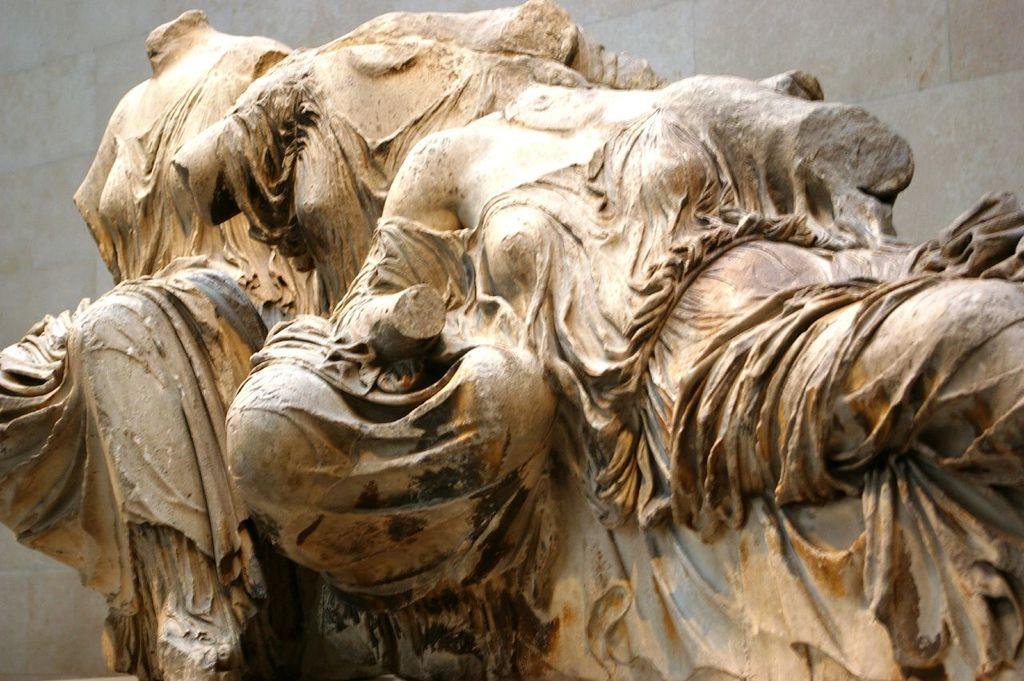What type of objects are depicted in the image? There are statues of persons in the image. Can you describe the setting of the image? There is a wall in the background of the image. What type of battle is taking place in the image? There is no battle present in the image; it features statues of persons and a wall in the background. What type of comb is being used by the statues in the image? There are no combs present in the image; it features statues of persons and a wall in the background. 